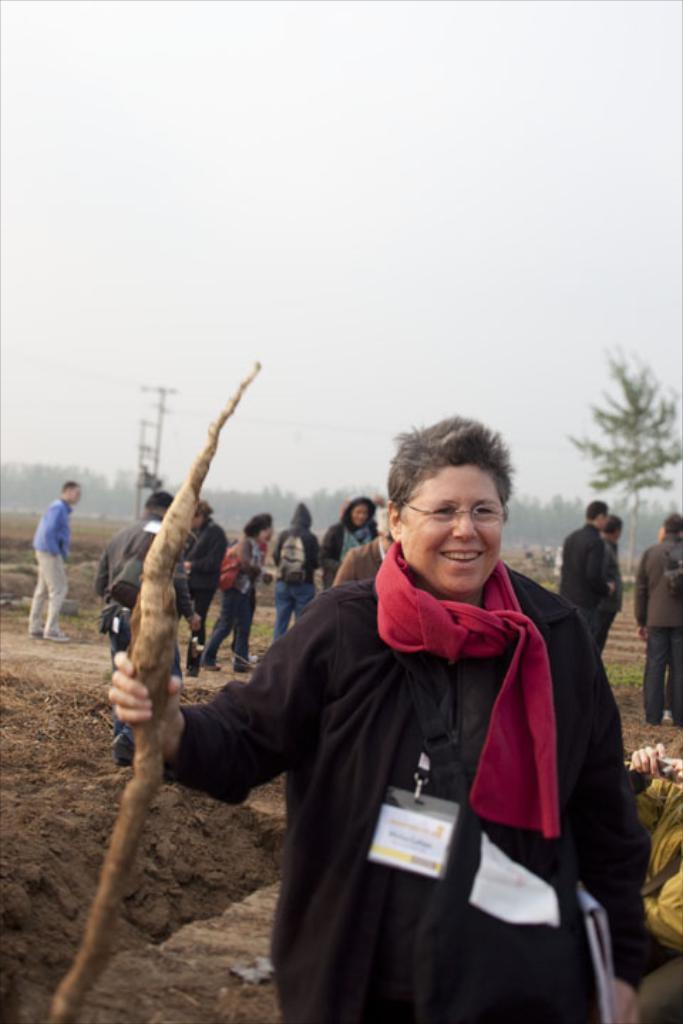In one or two sentences, can you explain what this image depicts? In the center of the image we can see a person standing and holding a stick. In the background there are people, trees, poles and sky. 